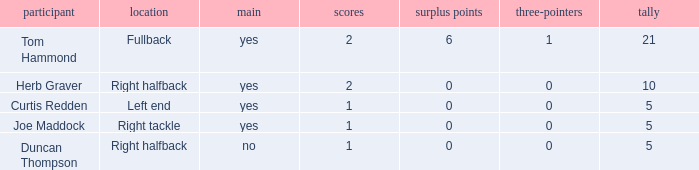Parse the table in full. {'header': ['participant', 'location', 'main', 'scores', 'surplus points', 'three-pointers', 'tally'], 'rows': [['Tom Hammond', 'Fullback', 'yes', '2', '6', '1', '21'], ['Herb Graver', 'Right halfback', 'yes', '2', '0', '0', '10'], ['Curtis Redden', 'Left end', 'yes', '1', '0', '0', '5'], ['Joe Maddock', 'Right tackle', 'yes', '1', '0', '0', '5'], ['Duncan Thompson', 'Right halfback', 'no', '1', '0', '0', '5']]} Name the number of points for field goals being 1 1.0. 